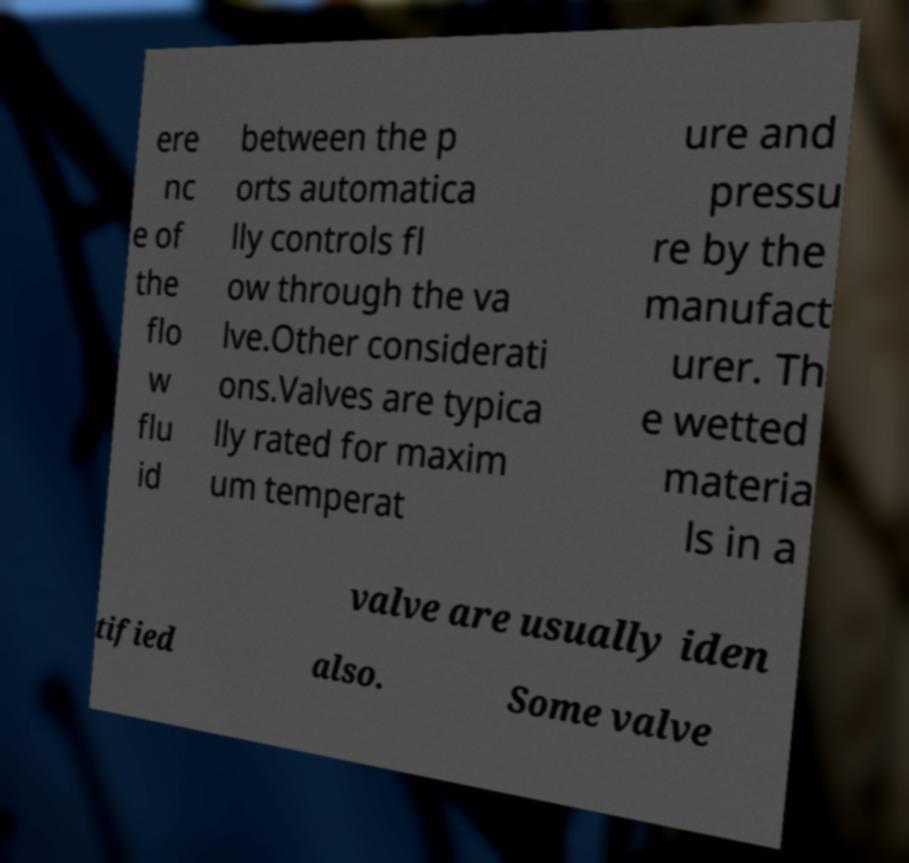Can you read and provide the text displayed in the image?This photo seems to have some interesting text. Can you extract and type it out for me? ere nc e of the flo w flu id between the p orts automatica lly controls fl ow through the va lve.Other considerati ons.Valves are typica lly rated for maxim um temperat ure and pressu re by the manufact urer. Th e wetted materia ls in a valve are usually iden tified also. Some valve 